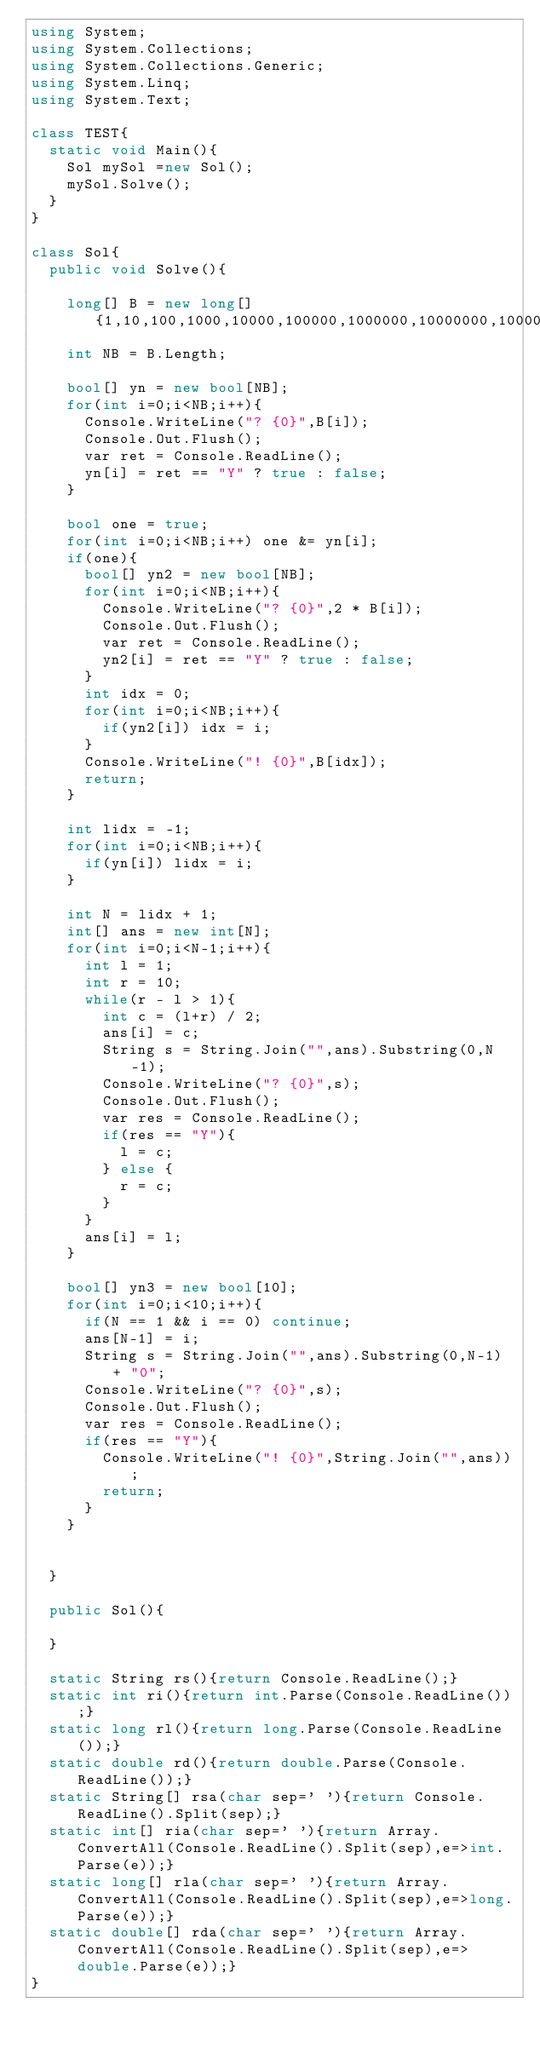Convert code to text. <code><loc_0><loc_0><loc_500><loc_500><_C#_>using System;
using System.Collections;
using System.Collections.Generic;
using System.Linq;
using System.Text;

class TEST{
	static void Main(){
		Sol mySol =new Sol();
		mySol.Solve();
	}
}

class Sol{
	public void Solve(){
		
		long[] B = new long[] {1,10,100,1000,10000,100000,1000000,10000000,100000000,1000000000};
		int NB = B.Length;
		
		bool[] yn = new bool[NB];
		for(int i=0;i<NB;i++){
			Console.WriteLine("? {0}",B[i]);
			Console.Out.Flush();
			var ret = Console.ReadLine();
			yn[i] = ret == "Y" ? true : false;
		}
		
		bool one = true;
		for(int i=0;i<NB;i++) one &= yn[i];
		if(one){
			bool[] yn2 = new bool[NB];
			for(int i=0;i<NB;i++){
				Console.WriteLine("? {0}",2 * B[i]);
				Console.Out.Flush();
				var ret = Console.ReadLine();
				yn2[i] = ret == "Y" ? true : false;
			}
			int idx = 0;
			for(int i=0;i<NB;i++){
				if(yn2[i]) idx = i;
			}
			Console.WriteLine("! {0}",B[idx]);
			return;
		}
		
		int lidx = -1;
		for(int i=0;i<NB;i++){
			if(yn[i]) lidx = i;
		}
		
		int N = lidx + 1;
		int[] ans = new int[N];
		for(int i=0;i<N-1;i++){
			int l = 1;
			int r = 10;
			while(r - l > 1){
				int c = (l+r) / 2;
				ans[i] = c;
				String s = String.Join("",ans).Substring(0,N-1);
				Console.WriteLine("? {0}",s);
				Console.Out.Flush();
				var res = Console.ReadLine();
				if(res == "Y"){
					l = c;
				} else {
					r = c;
				}
			}
			ans[i] = l;
		}
		
		bool[] yn3 = new bool[10];
		for(int i=0;i<10;i++){
			if(N == 1 && i == 0) continue;
			ans[N-1] = i;
			String s = String.Join("",ans).Substring(0,N-1) + "0";
			Console.WriteLine("? {0}",s);
			Console.Out.Flush();
			var res = Console.ReadLine();
			if(res == "Y"){
				Console.WriteLine("! {0}",String.Join("",ans));
				return;
			}
		}
		
		
	}

	public Sol(){
		
	}

	static String rs(){return Console.ReadLine();}
	static int ri(){return int.Parse(Console.ReadLine());}
	static long rl(){return long.Parse(Console.ReadLine());}
	static double rd(){return double.Parse(Console.ReadLine());}
	static String[] rsa(char sep=' '){return Console.ReadLine().Split(sep);}
	static int[] ria(char sep=' '){return Array.ConvertAll(Console.ReadLine().Split(sep),e=>int.Parse(e));}
	static long[] rla(char sep=' '){return Array.ConvertAll(Console.ReadLine().Split(sep),e=>long.Parse(e));}
	static double[] rda(char sep=' '){return Array.ConvertAll(Console.ReadLine().Split(sep),e=>double.Parse(e));}
}
</code> 